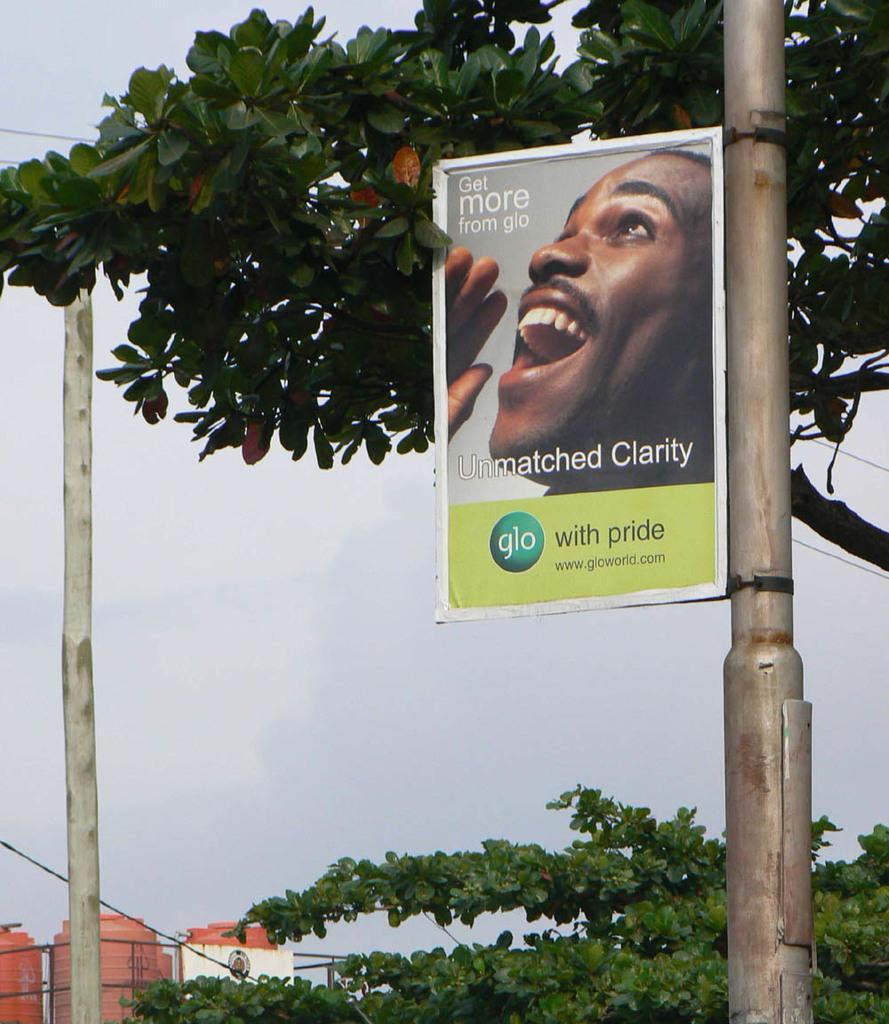Can you describe this image briefly? In this picture I can see buildings, trees and I can see a board to the pole and I can see text and a picture on the board and a wooden pole on the left side and I can see a cloudy sky. 